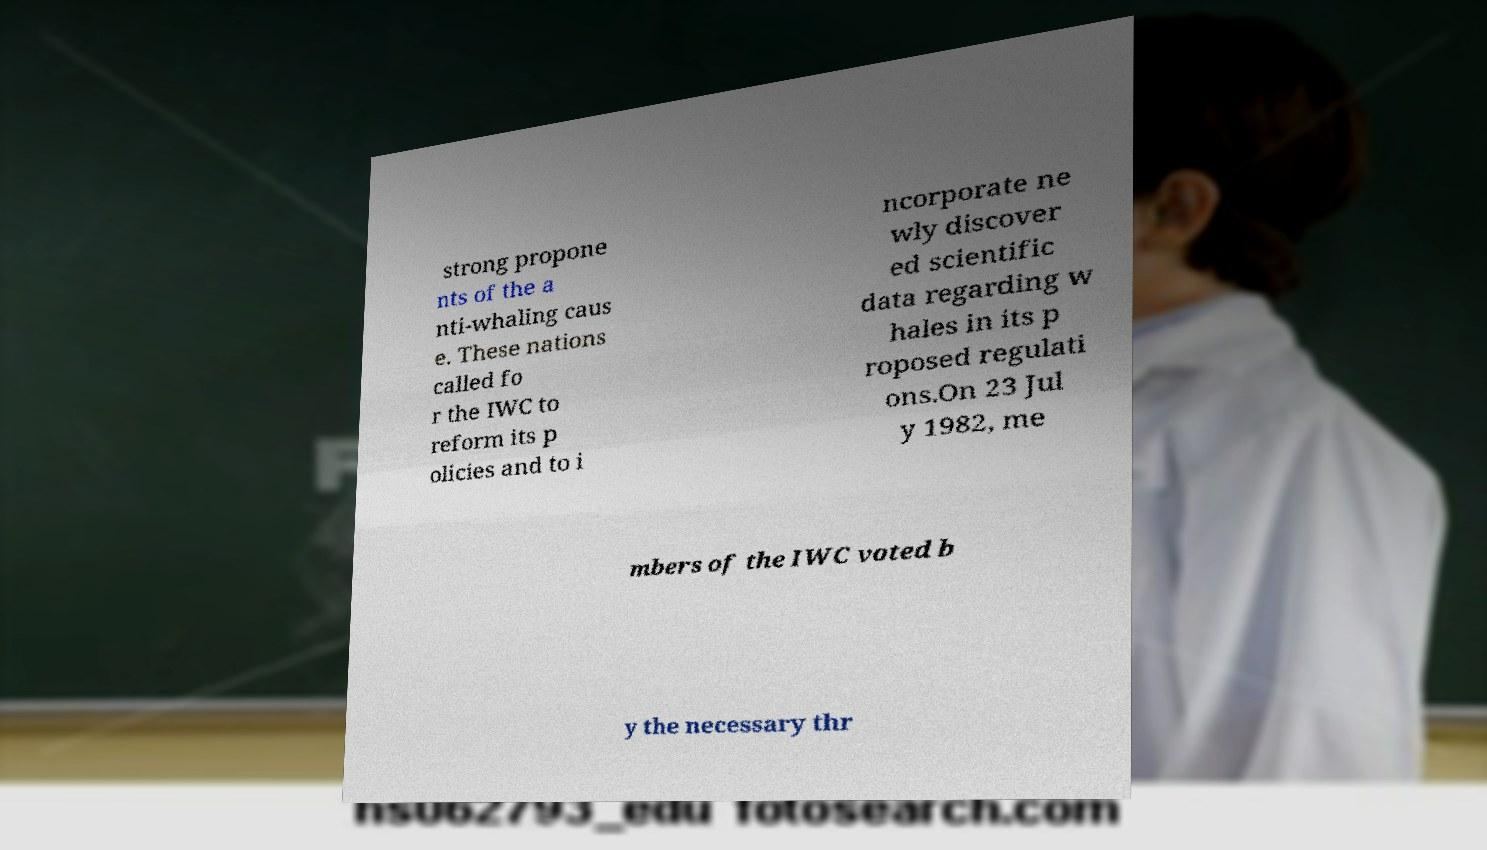Could you assist in decoding the text presented in this image and type it out clearly? strong propone nts of the a nti-whaling caus e. These nations called fo r the IWC to reform its p olicies and to i ncorporate ne wly discover ed scientific data regarding w hales in its p roposed regulati ons.On 23 Jul y 1982, me mbers of the IWC voted b y the necessary thr 